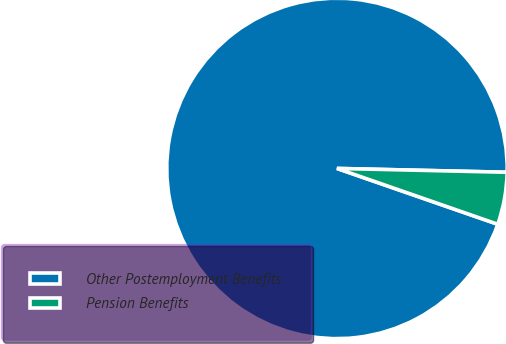Convert chart. <chart><loc_0><loc_0><loc_500><loc_500><pie_chart><fcel>Other Postemployment Benefits<fcel>Pension Benefits<nl><fcel>95.04%<fcel>4.96%<nl></chart> 